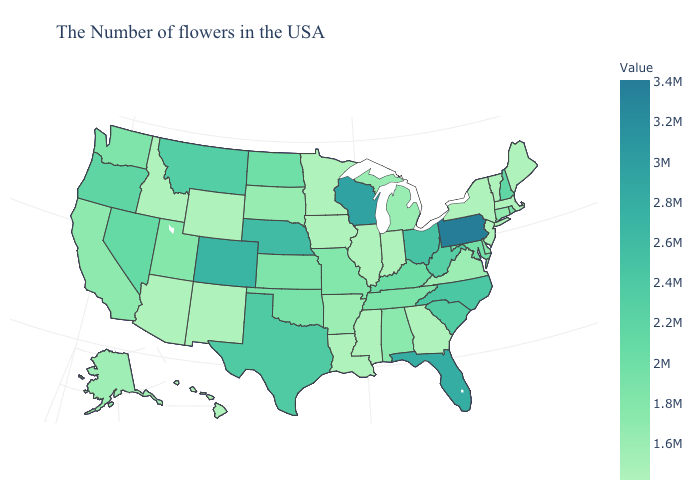Does the map have missing data?
Write a very short answer. No. Does the map have missing data?
Be succinct. No. Among the states that border Oklahoma , which have the lowest value?
Answer briefly. New Mexico. Is the legend a continuous bar?
Give a very brief answer. Yes. 